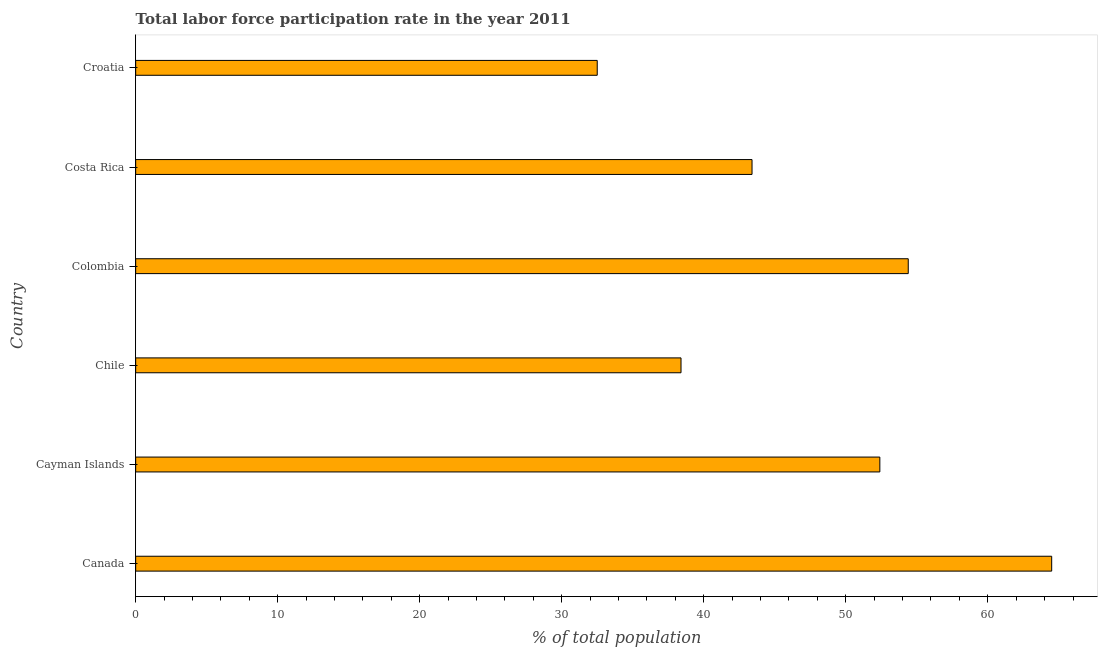Does the graph contain grids?
Give a very brief answer. No. What is the title of the graph?
Your response must be concise. Total labor force participation rate in the year 2011. What is the label or title of the X-axis?
Your response must be concise. % of total population. What is the total labor force participation rate in Cayman Islands?
Provide a succinct answer. 52.4. Across all countries, what is the maximum total labor force participation rate?
Ensure brevity in your answer.  64.5. Across all countries, what is the minimum total labor force participation rate?
Keep it short and to the point. 32.5. In which country was the total labor force participation rate maximum?
Offer a terse response. Canada. In which country was the total labor force participation rate minimum?
Offer a terse response. Croatia. What is the sum of the total labor force participation rate?
Keep it short and to the point. 285.6. What is the average total labor force participation rate per country?
Ensure brevity in your answer.  47.6. What is the median total labor force participation rate?
Your answer should be compact. 47.9. In how many countries, is the total labor force participation rate greater than 36 %?
Your answer should be compact. 5. What is the ratio of the total labor force participation rate in Chile to that in Colombia?
Ensure brevity in your answer.  0.71. Is the difference between the total labor force participation rate in Costa Rica and Croatia greater than the difference between any two countries?
Keep it short and to the point. No. What is the difference between the highest and the second highest total labor force participation rate?
Your answer should be compact. 10.1. Is the sum of the total labor force participation rate in Canada and Croatia greater than the maximum total labor force participation rate across all countries?
Provide a short and direct response. Yes. What is the difference between the highest and the lowest total labor force participation rate?
Offer a terse response. 32. In how many countries, is the total labor force participation rate greater than the average total labor force participation rate taken over all countries?
Provide a short and direct response. 3. What is the % of total population of Canada?
Offer a very short reply. 64.5. What is the % of total population of Cayman Islands?
Your answer should be compact. 52.4. What is the % of total population in Chile?
Your response must be concise. 38.4. What is the % of total population in Colombia?
Provide a succinct answer. 54.4. What is the % of total population of Costa Rica?
Keep it short and to the point. 43.4. What is the % of total population in Croatia?
Offer a terse response. 32.5. What is the difference between the % of total population in Canada and Cayman Islands?
Keep it short and to the point. 12.1. What is the difference between the % of total population in Canada and Chile?
Your answer should be very brief. 26.1. What is the difference between the % of total population in Canada and Costa Rica?
Ensure brevity in your answer.  21.1. What is the difference between the % of total population in Cayman Islands and Croatia?
Make the answer very short. 19.9. What is the difference between the % of total population in Chile and Costa Rica?
Offer a terse response. -5. What is the difference between the % of total population in Chile and Croatia?
Ensure brevity in your answer.  5.9. What is the difference between the % of total population in Colombia and Costa Rica?
Your answer should be compact. 11. What is the difference between the % of total population in Colombia and Croatia?
Offer a terse response. 21.9. What is the difference between the % of total population in Costa Rica and Croatia?
Give a very brief answer. 10.9. What is the ratio of the % of total population in Canada to that in Cayman Islands?
Offer a very short reply. 1.23. What is the ratio of the % of total population in Canada to that in Chile?
Keep it short and to the point. 1.68. What is the ratio of the % of total population in Canada to that in Colombia?
Give a very brief answer. 1.19. What is the ratio of the % of total population in Canada to that in Costa Rica?
Provide a short and direct response. 1.49. What is the ratio of the % of total population in Canada to that in Croatia?
Keep it short and to the point. 1.99. What is the ratio of the % of total population in Cayman Islands to that in Chile?
Provide a succinct answer. 1.36. What is the ratio of the % of total population in Cayman Islands to that in Costa Rica?
Provide a succinct answer. 1.21. What is the ratio of the % of total population in Cayman Islands to that in Croatia?
Ensure brevity in your answer.  1.61. What is the ratio of the % of total population in Chile to that in Colombia?
Provide a short and direct response. 0.71. What is the ratio of the % of total population in Chile to that in Costa Rica?
Offer a terse response. 0.89. What is the ratio of the % of total population in Chile to that in Croatia?
Give a very brief answer. 1.18. What is the ratio of the % of total population in Colombia to that in Costa Rica?
Offer a very short reply. 1.25. What is the ratio of the % of total population in Colombia to that in Croatia?
Ensure brevity in your answer.  1.67. What is the ratio of the % of total population in Costa Rica to that in Croatia?
Your response must be concise. 1.33. 